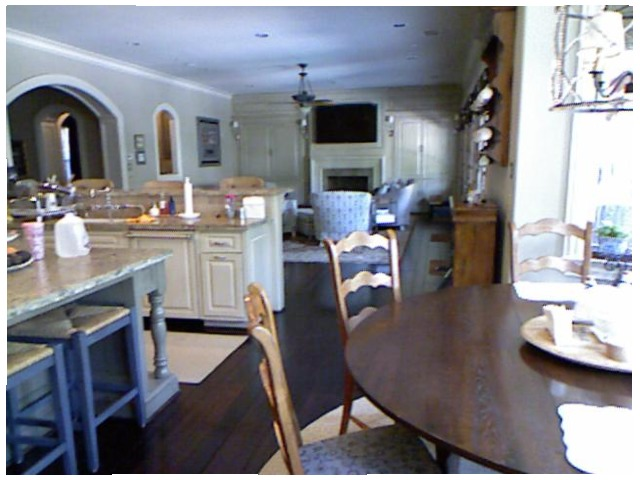<image>
Is the tv on the counter? No. The tv is not positioned on the counter. They may be near each other, but the tv is not supported by or resting on top of the counter. Is there a cup above the gallon? No. The cup is not positioned above the gallon. The vertical arrangement shows a different relationship. Where is the chair in relation to the tv? Is it next to the tv? No. The chair is not positioned next to the tv. They are located in different areas of the scene. 